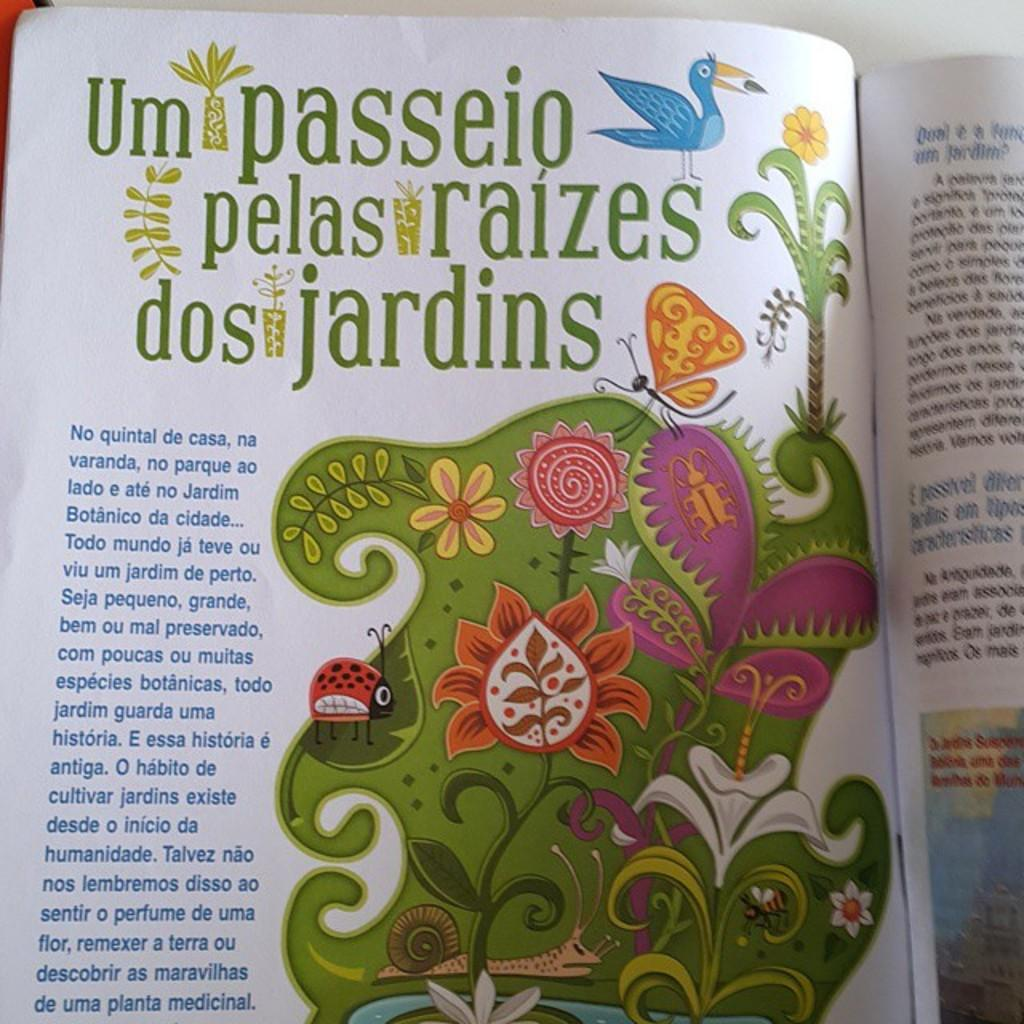<image>
Share a concise interpretation of the image provided. A book is open to a colorful page that says um passeio at the beginning of the header. 